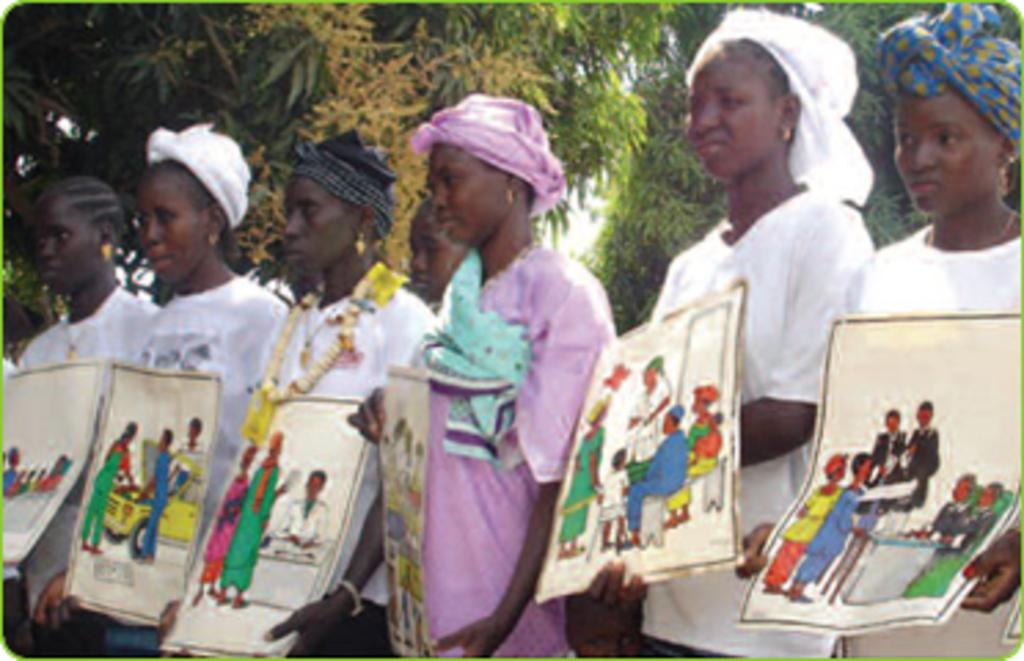What are the people in the image doing? The people in the image are standing and holding papers. What is depicted on the papers they are holding? The papers contain paintings. What can be seen in the background of the image? There are trees in the background of the image. What type of soup is being served in the image? There is no soup present in the image; it features people holding papers with paintings. Can you describe the umbrella being used by the people in the image? There is no umbrella present in the image; the people are holding papers with paintings. 